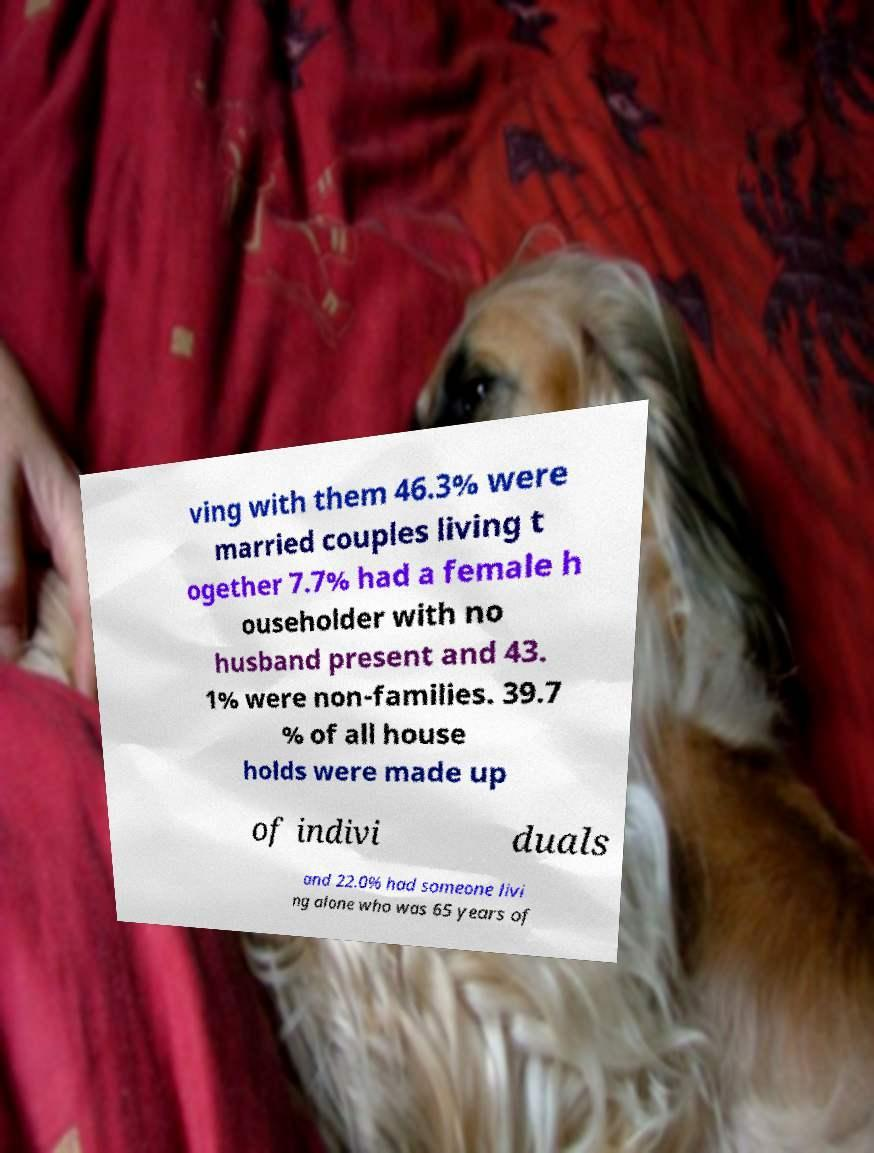Could you extract and type out the text from this image? ving with them 46.3% were married couples living t ogether 7.7% had a female h ouseholder with no husband present and 43. 1% were non-families. 39.7 % of all house holds were made up of indivi duals and 22.0% had someone livi ng alone who was 65 years of 